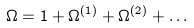<formula> <loc_0><loc_0><loc_500><loc_500>\Omega = 1 + \Omega ^ { ( 1 ) } + \Omega ^ { ( 2 ) } + \dots</formula> 